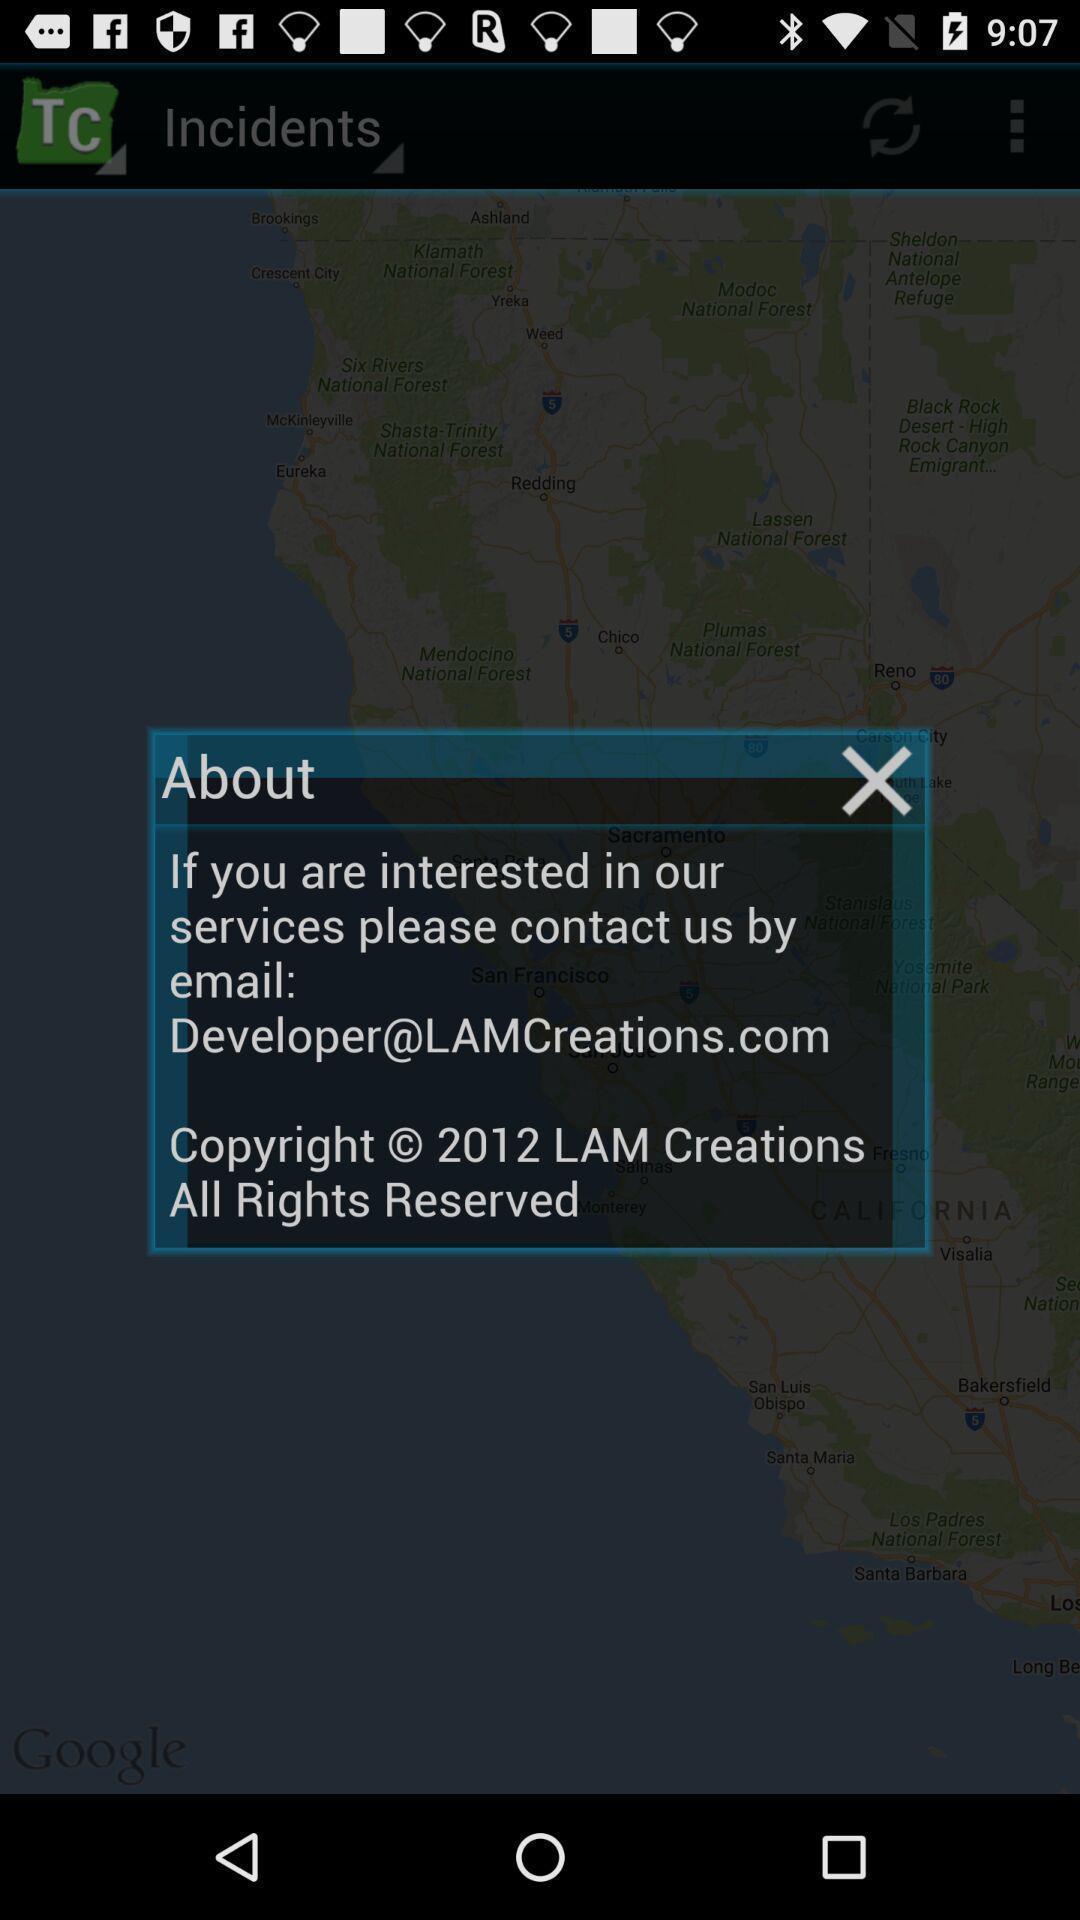What details can you identify in this image? Pop-up for contact and email information details. 